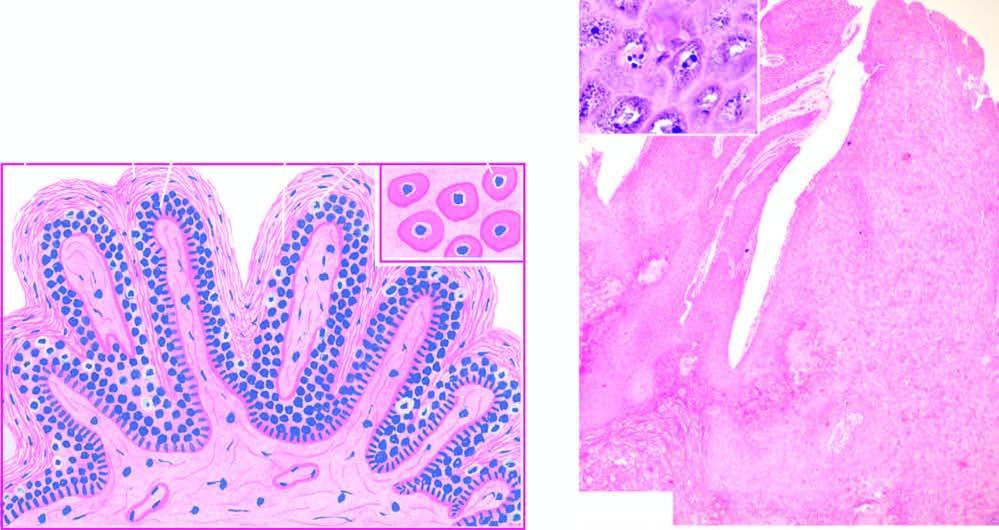re foci of vacuolated cells found in the upper stratum malpighii?
Answer the question using a single word or phrase. Yes 